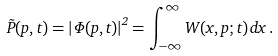<formula> <loc_0><loc_0><loc_500><loc_500>\tilde { P } ( p , t ) = \left | \Phi ( p , t ) \right | ^ { 2 } = \int _ { - \infty } ^ { \infty } { W ( x , p ; t ) \, d x } \, .</formula> 